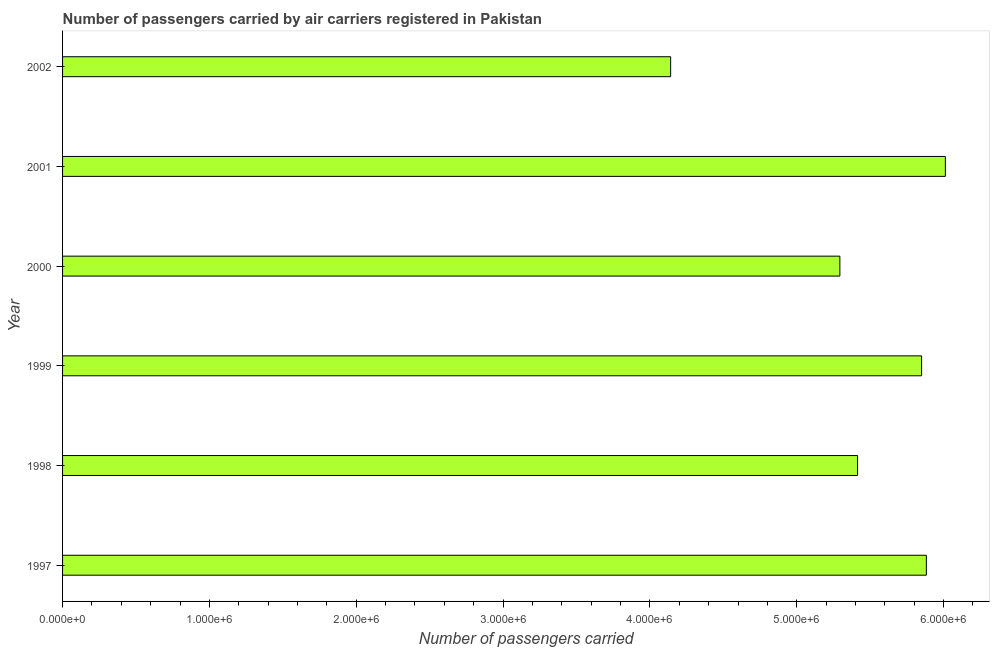Does the graph contain any zero values?
Make the answer very short. No. Does the graph contain grids?
Your answer should be very brief. No. What is the title of the graph?
Provide a short and direct response. Number of passengers carried by air carriers registered in Pakistan. What is the label or title of the X-axis?
Ensure brevity in your answer.  Number of passengers carried. What is the label or title of the Y-axis?
Keep it short and to the point. Year. What is the number of passengers carried in 1999?
Give a very brief answer. 5.85e+06. Across all years, what is the maximum number of passengers carried?
Your answer should be very brief. 6.01e+06. Across all years, what is the minimum number of passengers carried?
Your response must be concise. 4.14e+06. In which year was the number of passengers carried maximum?
Provide a short and direct response. 2001. In which year was the number of passengers carried minimum?
Offer a terse response. 2002. What is the sum of the number of passengers carried?
Your answer should be very brief. 3.26e+07. What is the difference between the number of passengers carried in 1999 and 2000?
Make the answer very short. 5.56e+05. What is the average number of passengers carried per year?
Provide a short and direct response. 5.43e+06. What is the median number of passengers carried?
Keep it short and to the point. 5.63e+06. In how many years, is the number of passengers carried greater than 2000000 ?
Your answer should be very brief. 6. Do a majority of the years between 2002 and 1997 (inclusive) have number of passengers carried greater than 800000 ?
Your response must be concise. Yes. What is the ratio of the number of passengers carried in 1999 to that in 2001?
Offer a terse response. 0.97. Is the number of passengers carried in 1998 less than that in 2000?
Your answer should be compact. No. Is the difference between the number of passengers carried in 1998 and 2001 greater than the difference between any two years?
Make the answer very short. No. What is the difference between the highest and the second highest number of passengers carried?
Ensure brevity in your answer.  1.29e+05. What is the difference between the highest and the lowest number of passengers carried?
Offer a terse response. 1.87e+06. In how many years, is the number of passengers carried greater than the average number of passengers carried taken over all years?
Give a very brief answer. 3. How many bars are there?
Your answer should be compact. 6. Are all the bars in the graph horizontal?
Keep it short and to the point. Yes. What is the Number of passengers carried in 1997?
Keep it short and to the point. 5.88e+06. What is the Number of passengers carried of 1998?
Provide a succinct answer. 5.41e+06. What is the Number of passengers carried of 1999?
Give a very brief answer. 5.85e+06. What is the Number of passengers carried of 2000?
Keep it short and to the point. 5.29e+06. What is the Number of passengers carried in 2001?
Your response must be concise. 6.01e+06. What is the Number of passengers carried in 2002?
Keep it short and to the point. 4.14e+06. What is the difference between the Number of passengers carried in 1997 and 1998?
Make the answer very short. 4.68e+05. What is the difference between the Number of passengers carried in 1997 and 1999?
Your response must be concise. 3.25e+04. What is the difference between the Number of passengers carried in 1997 and 2000?
Give a very brief answer. 5.89e+05. What is the difference between the Number of passengers carried in 1997 and 2001?
Ensure brevity in your answer.  -1.29e+05. What is the difference between the Number of passengers carried in 1997 and 2002?
Provide a short and direct response. 1.74e+06. What is the difference between the Number of passengers carried in 1998 and 1999?
Provide a succinct answer. -4.36e+05. What is the difference between the Number of passengers carried in 1998 and 2000?
Provide a succinct answer. 1.21e+05. What is the difference between the Number of passengers carried in 1998 and 2001?
Keep it short and to the point. -5.98e+05. What is the difference between the Number of passengers carried in 1998 and 2002?
Offer a very short reply. 1.27e+06. What is the difference between the Number of passengers carried in 1999 and 2000?
Offer a terse response. 5.56e+05. What is the difference between the Number of passengers carried in 1999 and 2001?
Offer a very short reply. -1.62e+05. What is the difference between the Number of passengers carried in 1999 and 2002?
Provide a succinct answer. 1.71e+06. What is the difference between the Number of passengers carried in 2000 and 2001?
Offer a very short reply. -7.18e+05. What is the difference between the Number of passengers carried in 2000 and 2002?
Provide a short and direct response. 1.15e+06. What is the difference between the Number of passengers carried in 2001 and 2002?
Your response must be concise. 1.87e+06. What is the ratio of the Number of passengers carried in 1997 to that in 1998?
Offer a very short reply. 1.09. What is the ratio of the Number of passengers carried in 1997 to that in 1999?
Provide a short and direct response. 1.01. What is the ratio of the Number of passengers carried in 1997 to that in 2000?
Give a very brief answer. 1.11. What is the ratio of the Number of passengers carried in 1997 to that in 2001?
Your answer should be compact. 0.98. What is the ratio of the Number of passengers carried in 1997 to that in 2002?
Keep it short and to the point. 1.42. What is the ratio of the Number of passengers carried in 1998 to that in 1999?
Ensure brevity in your answer.  0.93. What is the ratio of the Number of passengers carried in 1998 to that in 2001?
Keep it short and to the point. 0.9. What is the ratio of the Number of passengers carried in 1998 to that in 2002?
Offer a terse response. 1.31. What is the ratio of the Number of passengers carried in 1999 to that in 2000?
Your answer should be very brief. 1.1. What is the ratio of the Number of passengers carried in 1999 to that in 2002?
Provide a short and direct response. 1.41. What is the ratio of the Number of passengers carried in 2000 to that in 2001?
Provide a short and direct response. 0.88. What is the ratio of the Number of passengers carried in 2000 to that in 2002?
Your answer should be very brief. 1.28. What is the ratio of the Number of passengers carried in 2001 to that in 2002?
Keep it short and to the point. 1.45. 